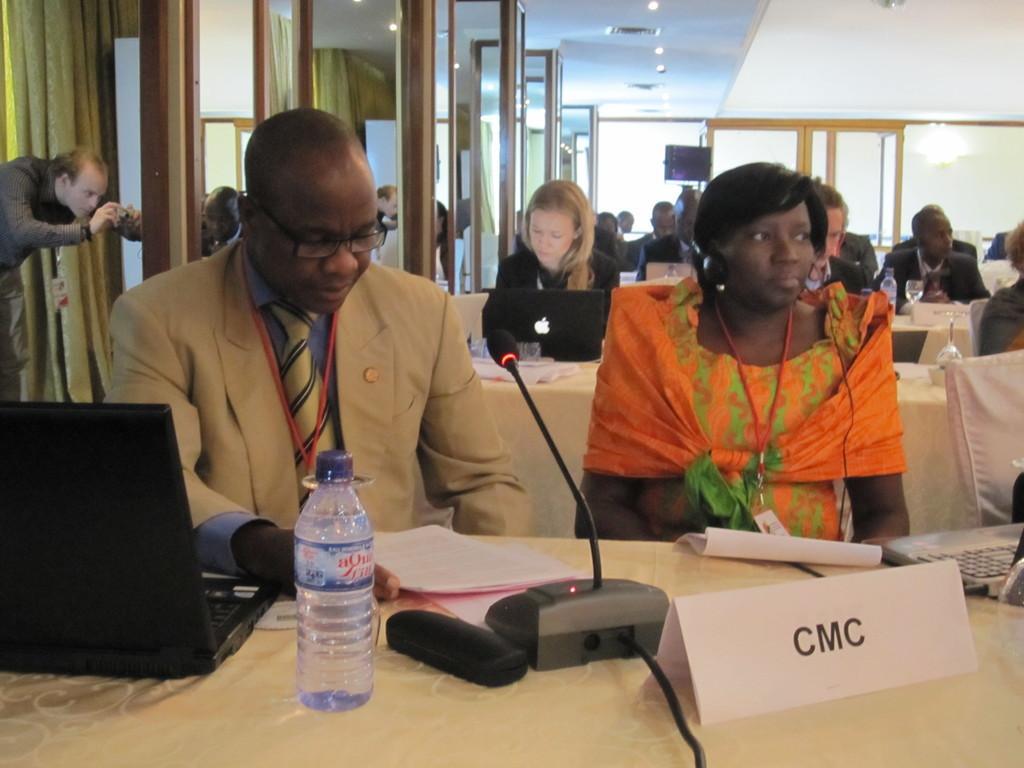Could you give a brief overview of what you see in this image? In the image there are few men in suits and women sitting in front of table with laptops,mics,water bottles on it, this seems to be a conference,there are doors on the left side and lights over the ceiling and a man standing and taking pictures on the left side. 